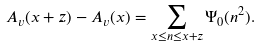<formula> <loc_0><loc_0><loc_500><loc_500>A _ { v } ( x + z ) - A _ { v } ( x ) = \sum _ { x \leq n \leq x + z } \Psi _ { 0 } ( n ^ { 2 } ) .</formula> 